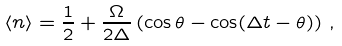Convert formula to latex. <formula><loc_0><loc_0><loc_500><loc_500>\langle n \rangle = { \frac { 1 } { 2 } } + { \frac { \Omega } { 2 \Delta } } \left ( \cos \theta - \cos ( \Delta t - \theta ) \right ) \, ,</formula> 